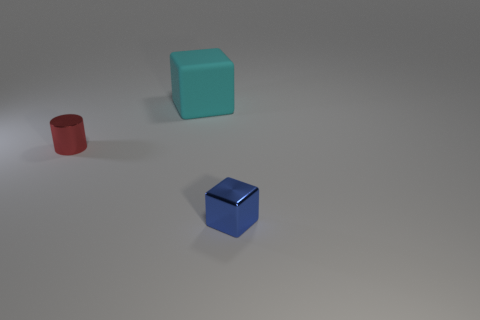Add 1 small cyan cylinders. How many objects exist? 4 Subtract all cylinders. How many objects are left? 2 Add 1 blue metallic blocks. How many blue metallic blocks exist? 2 Subtract 0 purple cubes. How many objects are left? 3 Subtract all small metallic cylinders. Subtract all red shiny things. How many objects are left? 1 Add 1 rubber cubes. How many rubber cubes are left? 2 